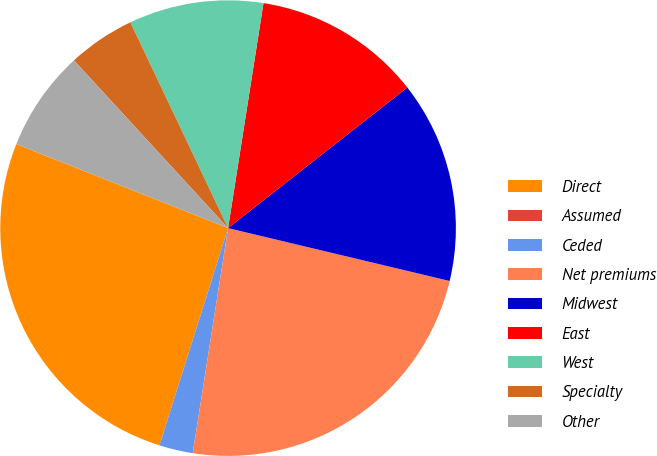Convert chart. <chart><loc_0><loc_0><loc_500><loc_500><pie_chart><fcel>Direct<fcel>Assumed<fcel>Ceded<fcel>Net premiums<fcel>Midwest<fcel>East<fcel>West<fcel>Specialty<fcel>Other<nl><fcel>26.14%<fcel>0.0%<fcel>2.39%<fcel>23.75%<fcel>14.31%<fcel>11.93%<fcel>9.54%<fcel>4.77%<fcel>7.16%<nl></chart> 